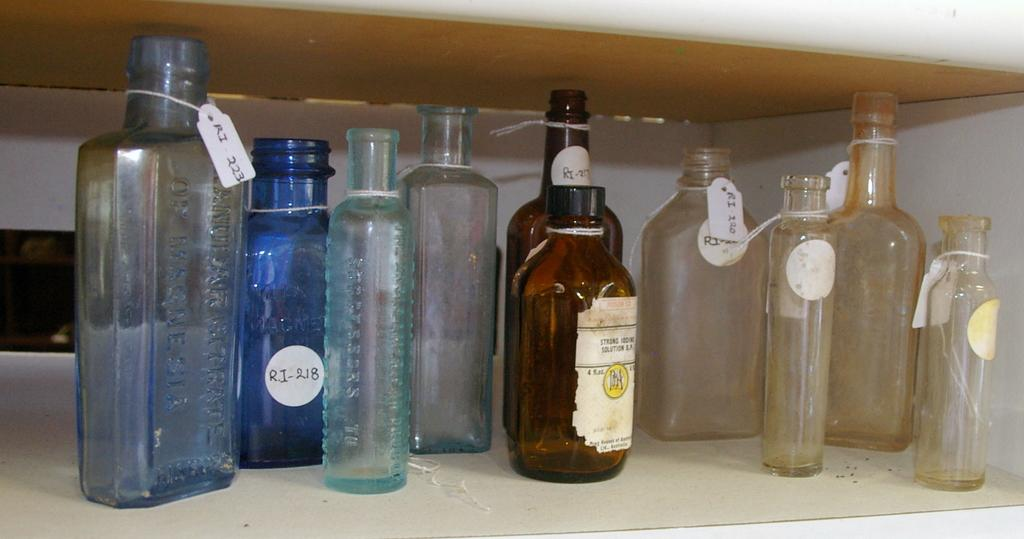<image>
Share a concise interpretation of the image provided. Various old empty bottles ona shelf, mostly labeled "RI-" with tags. 